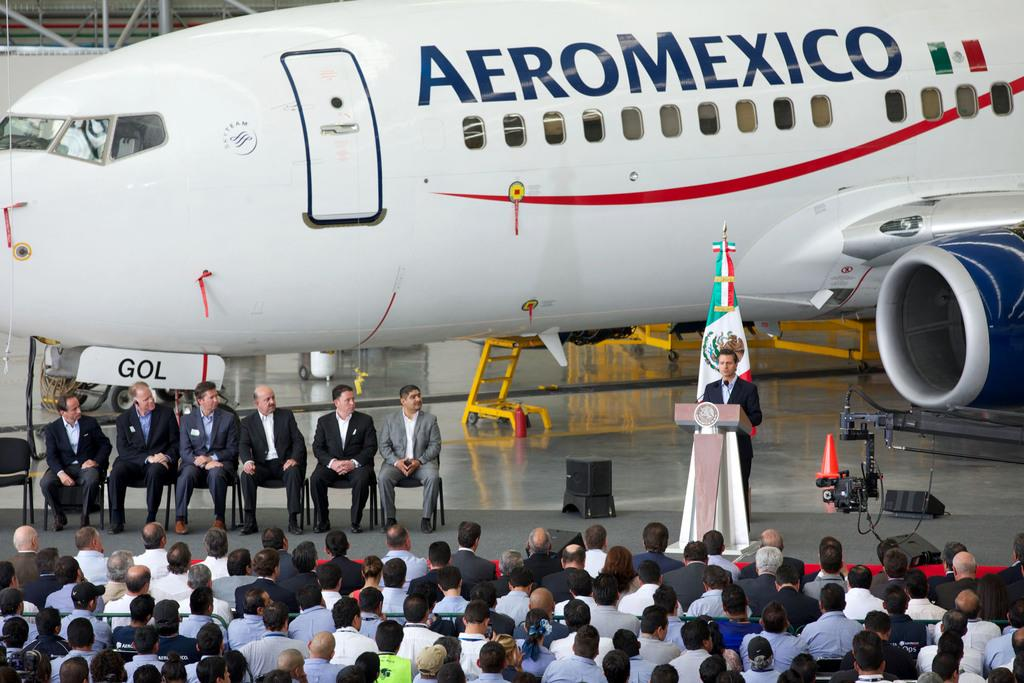<image>
Describe the image concisely. White Aeromexico airplane parked behind people watching a speech. 